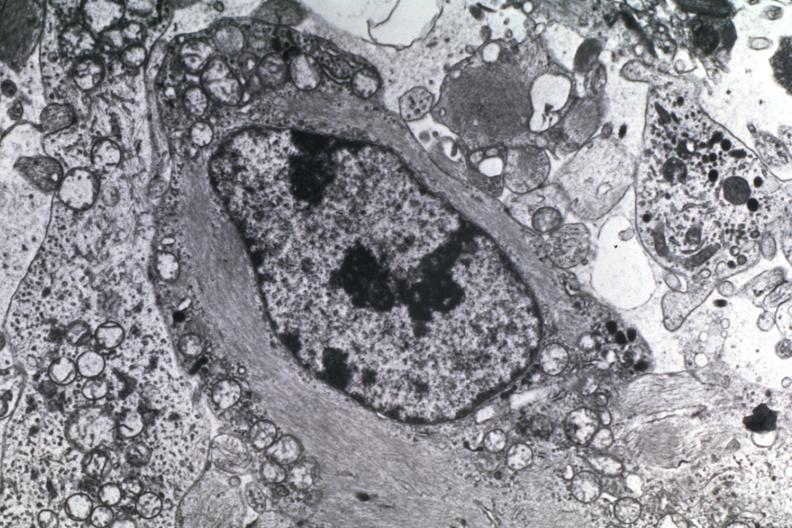what is present?
Answer the question using a single word or phrase. Brain 